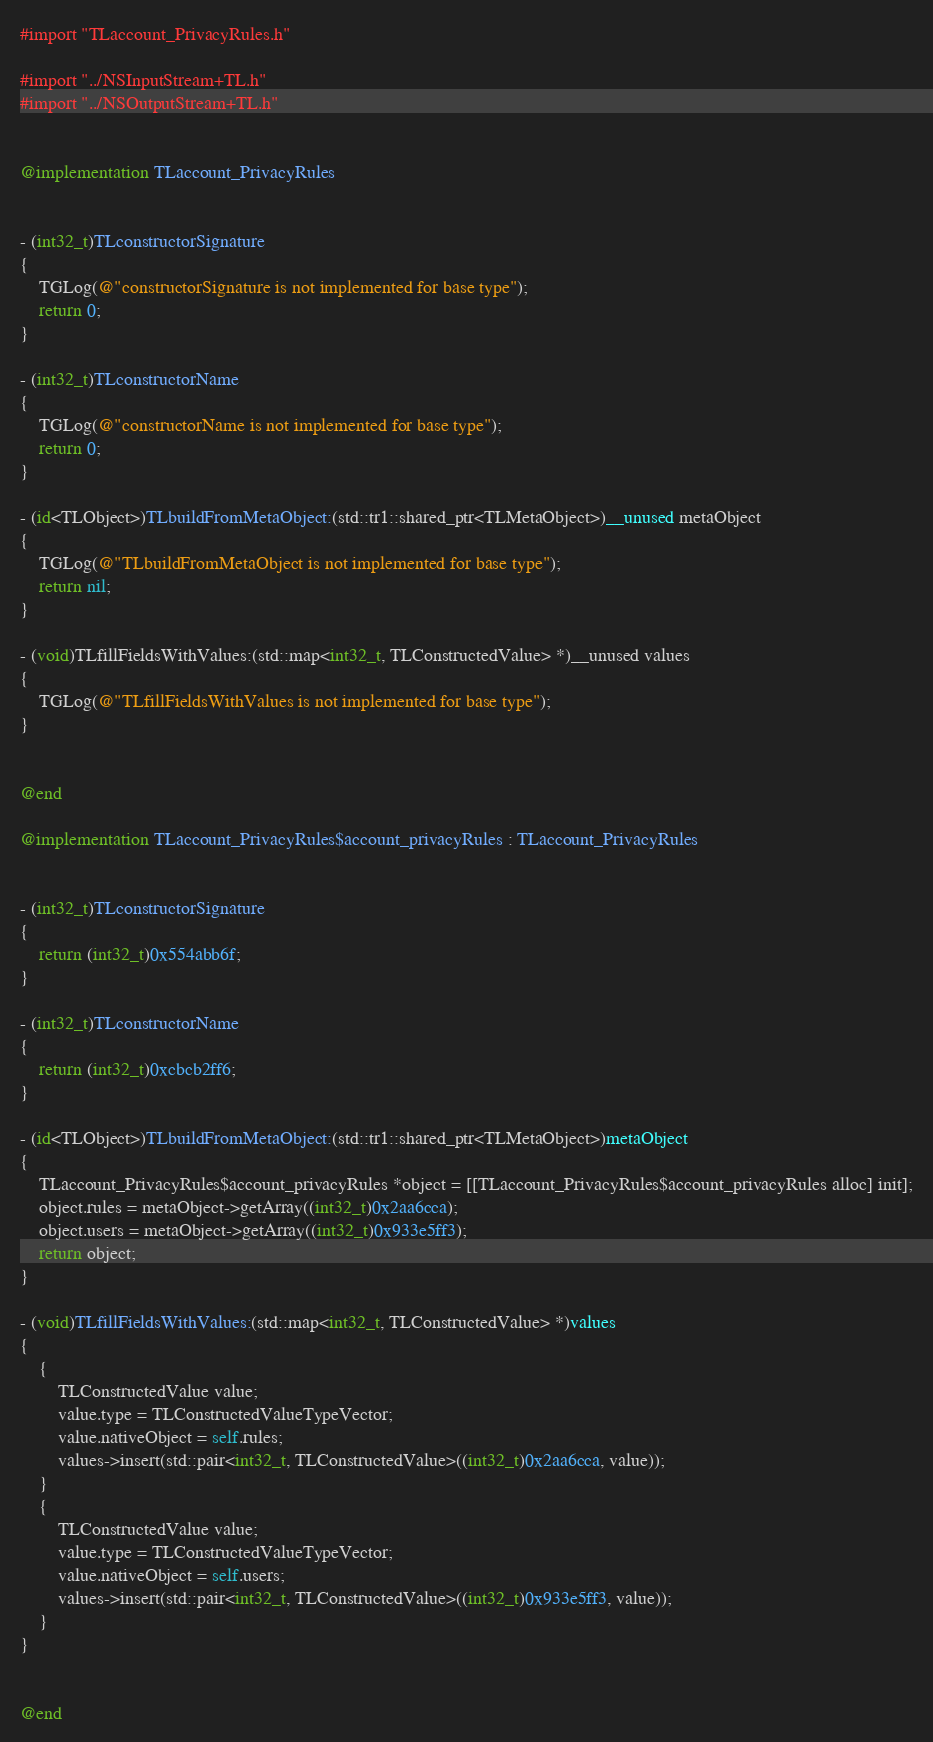Convert code to text. <code><loc_0><loc_0><loc_500><loc_500><_ObjectiveC_>#import "TLaccount_PrivacyRules.h"

#import "../NSInputStream+TL.h"
#import "../NSOutputStream+TL.h"


@implementation TLaccount_PrivacyRules


- (int32_t)TLconstructorSignature
{
    TGLog(@"constructorSignature is not implemented for base type");
    return 0;
}

- (int32_t)TLconstructorName
{
    TGLog(@"constructorName is not implemented for base type");
    return 0;
}

- (id<TLObject>)TLbuildFromMetaObject:(std::tr1::shared_ptr<TLMetaObject>)__unused metaObject
{
    TGLog(@"TLbuildFromMetaObject is not implemented for base type");
    return nil;
}

- (void)TLfillFieldsWithValues:(std::map<int32_t, TLConstructedValue> *)__unused values
{
    TGLog(@"TLfillFieldsWithValues is not implemented for base type");
}


@end

@implementation TLaccount_PrivacyRules$account_privacyRules : TLaccount_PrivacyRules


- (int32_t)TLconstructorSignature
{
    return (int32_t)0x554abb6f;
}

- (int32_t)TLconstructorName
{
    return (int32_t)0xcbcb2ff6;
}

- (id<TLObject>)TLbuildFromMetaObject:(std::tr1::shared_ptr<TLMetaObject>)metaObject
{
    TLaccount_PrivacyRules$account_privacyRules *object = [[TLaccount_PrivacyRules$account_privacyRules alloc] init];
    object.rules = metaObject->getArray((int32_t)0x2aa6cca);
    object.users = metaObject->getArray((int32_t)0x933e5ff3);
    return object;
}

- (void)TLfillFieldsWithValues:(std::map<int32_t, TLConstructedValue> *)values
{
    {
        TLConstructedValue value;
        value.type = TLConstructedValueTypeVector;
        value.nativeObject = self.rules;
        values->insert(std::pair<int32_t, TLConstructedValue>((int32_t)0x2aa6cca, value));
    }
    {
        TLConstructedValue value;
        value.type = TLConstructedValueTypeVector;
        value.nativeObject = self.users;
        values->insert(std::pair<int32_t, TLConstructedValue>((int32_t)0x933e5ff3, value));
    }
}


@end

</code> 